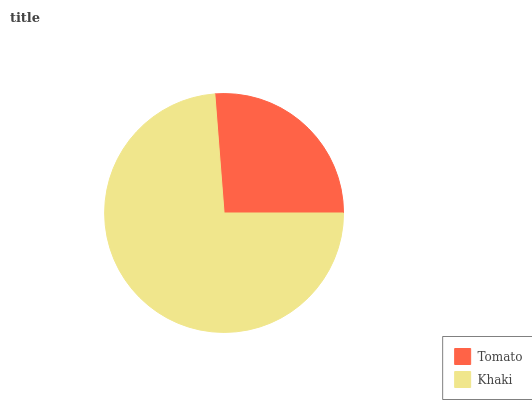Is Tomato the minimum?
Answer yes or no. Yes. Is Khaki the maximum?
Answer yes or no. Yes. Is Khaki the minimum?
Answer yes or no. No. Is Khaki greater than Tomato?
Answer yes or no. Yes. Is Tomato less than Khaki?
Answer yes or no. Yes. Is Tomato greater than Khaki?
Answer yes or no. No. Is Khaki less than Tomato?
Answer yes or no. No. Is Khaki the high median?
Answer yes or no. Yes. Is Tomato the low median?
Answer yes or no. Yes. Is Tomato the high median?
Answer yes or no. No. Is Khaki the low median?
Answer yes or no. No. 